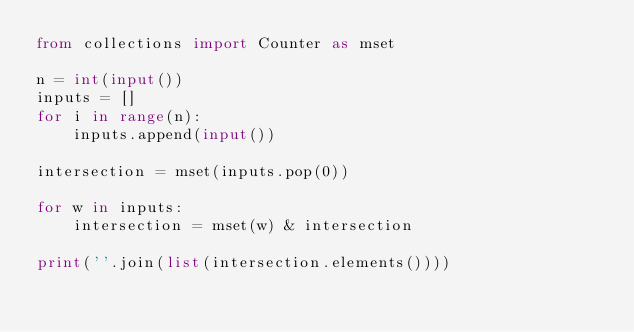Convert code to text. <code><loc_0><loc_0><loc_500><loc_500><_Python_>from collections import Counter as mset

n = int(input())
inputs = []
for i in range(n):
    inputs.append(input())

intersection = mset(inputs.pop(0))

for w in inputs:
    intersection = mset(w) & intersection

print(''.join(list(intersection.elements())))</code> 